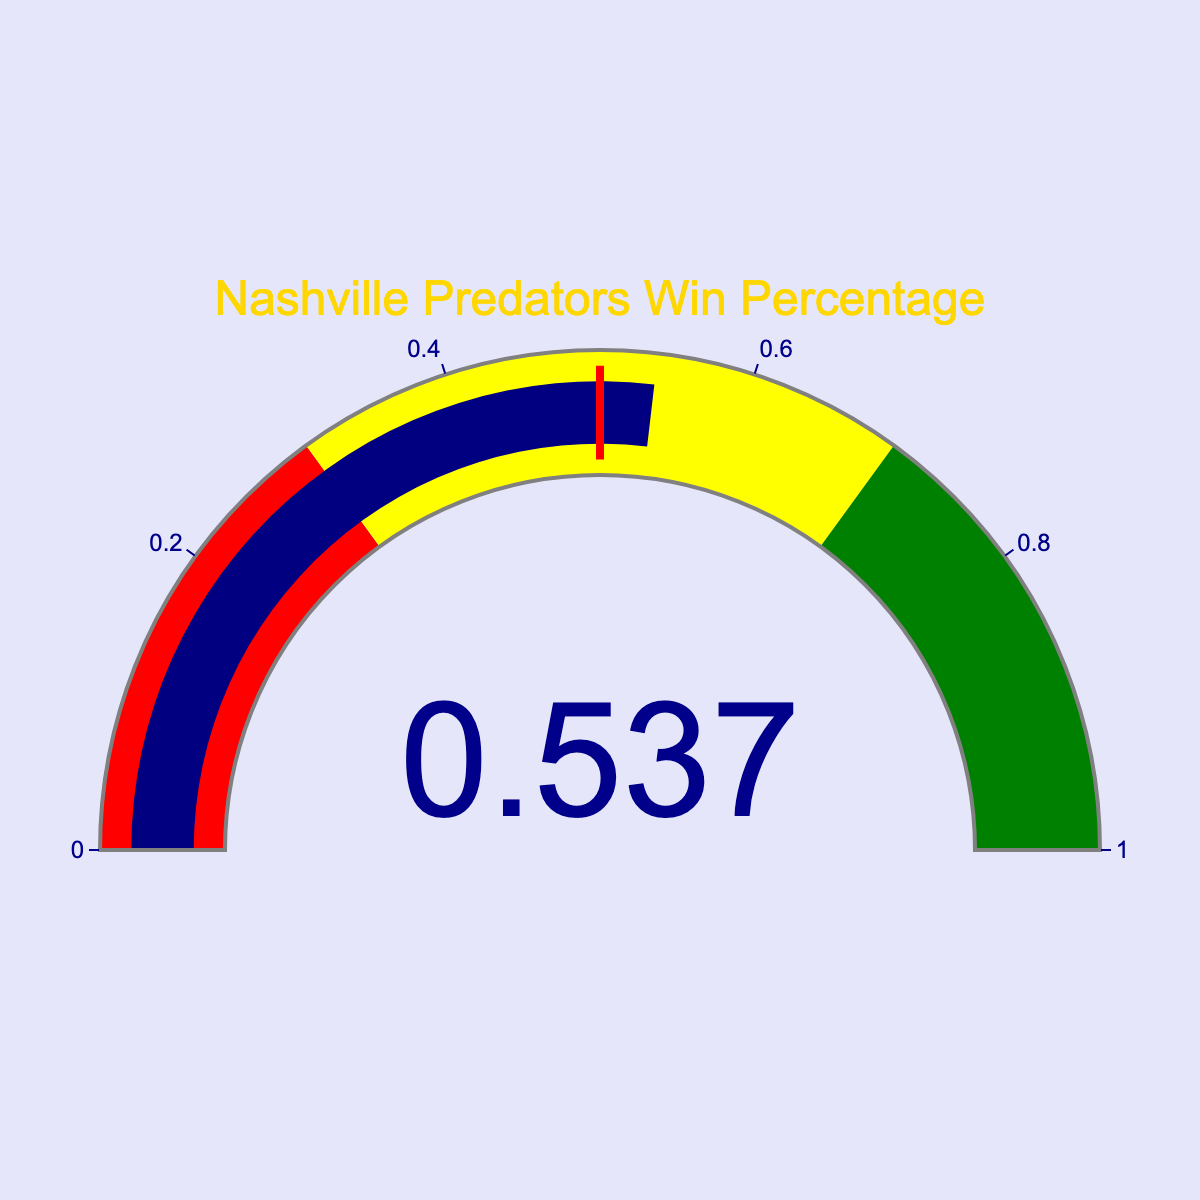What is the current win percentage of the Nashville Predators for the season? The gauge chart shows the win percentage in a numerical value format. According to the figure, the value displayed is 0.537.
Answer: 0.537 In which color zone does the Nashville Predators' win percentage fall? The gauge is divided into three color zones: red for [0, 0.3], yellow for [0.3, 0.7], and green for [0.7, 1]. The Predators' win percentage of 0.537 falls within the yellow range.
Answer: Yellow What does the red threshold line on the gauge indicate? The red threshold line on the gauge represents a critical value, typically used to highlight a significant benchmark or threshold. For the given gauge, the threshold line is set at a value of 0.5.
Answer: 0.5 How much higher is the win percentage of the Nashville Predators compared to the threshold value indicated by the red line? The Predators’ win percentage is 0.537, and the threshold value is 0.5. Subtract the threshold value from the win percentage: 0.537 - 0.5 = 0.037.
Answer: 0.037 Is the Nashville Predators' win percentage closer to the minimum or maximum end of the yellow zone on the gauge? The yellow zone ranges from 0.3 to 0.7. The middle point of the yellow zone is (0.3 + 0.7) / 2 = 0.5. The Predators' win percentage (0.537) is closer to 0.7 (the maximum end of yellow zone).
Answer: Maximum end of yellow zone Where on the gauge (which zones) does the win percentage not reach? The gauge zones range from red [0, 0.3], yellow [0.3, 0.7], and green [0.7, 1]. Since the win percentage is 0.537, it does not reach the red [0, 0.3] and green [0.7, 1] zones.
Answer: Red and Green If the win percentage of another team was 0.2, which color zone would it fall into on this gauge? A win percentage of 0.2 falls within the red color zone of the gauge, which covers the range from 0 to 0.3.
Answer: Red 